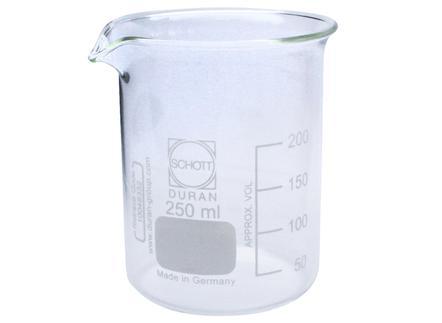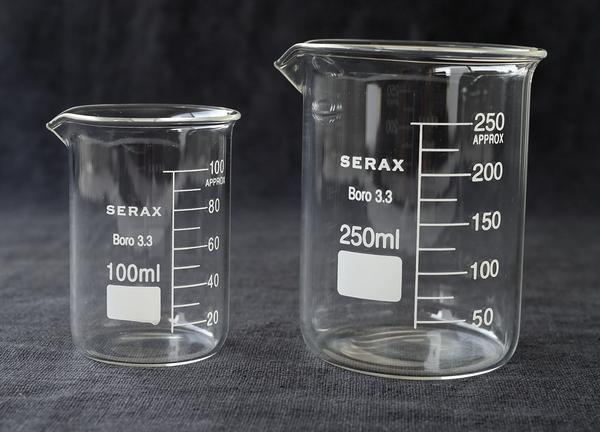The first image is the image on the left, the second image is the image on the right. For the images shown, is this caption "There are just two beakers, and they are both on a dark background." true? Answer yes or no. No. 